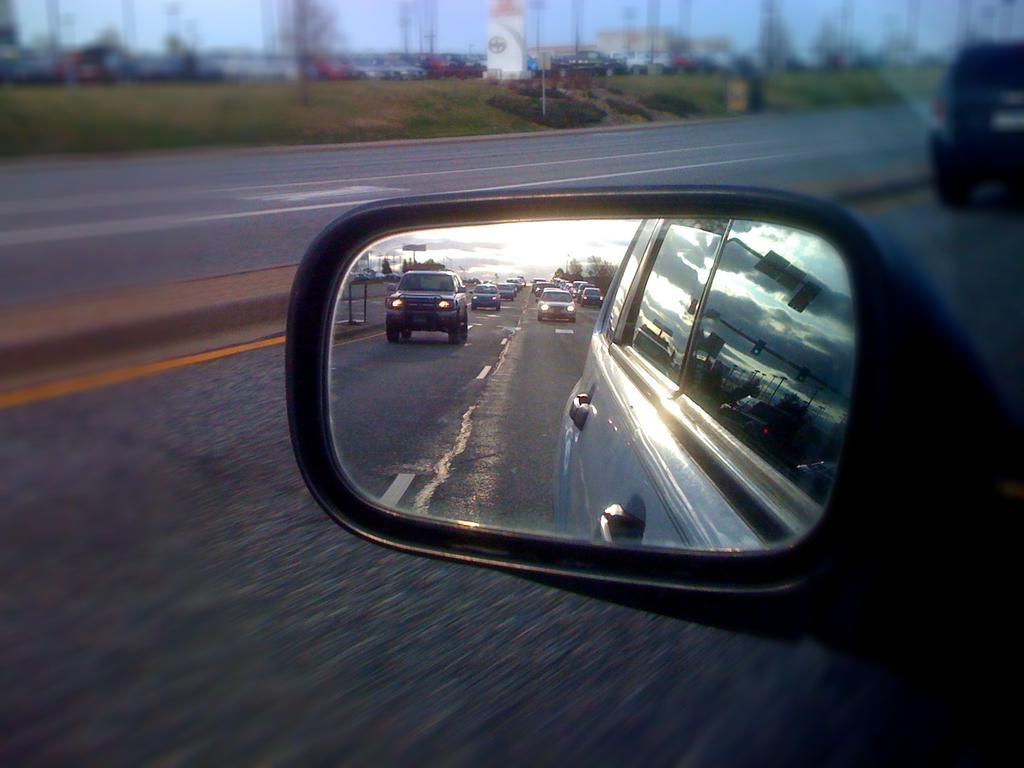Please provide a concise description of this image. In this image we can see a mirror of a vehicle in which we can see some vehicles on the road, some trees and the sky. On the backside we can see a group of vehicles on the ground. We can also see some grass, poles, a board, a building and the sky. 